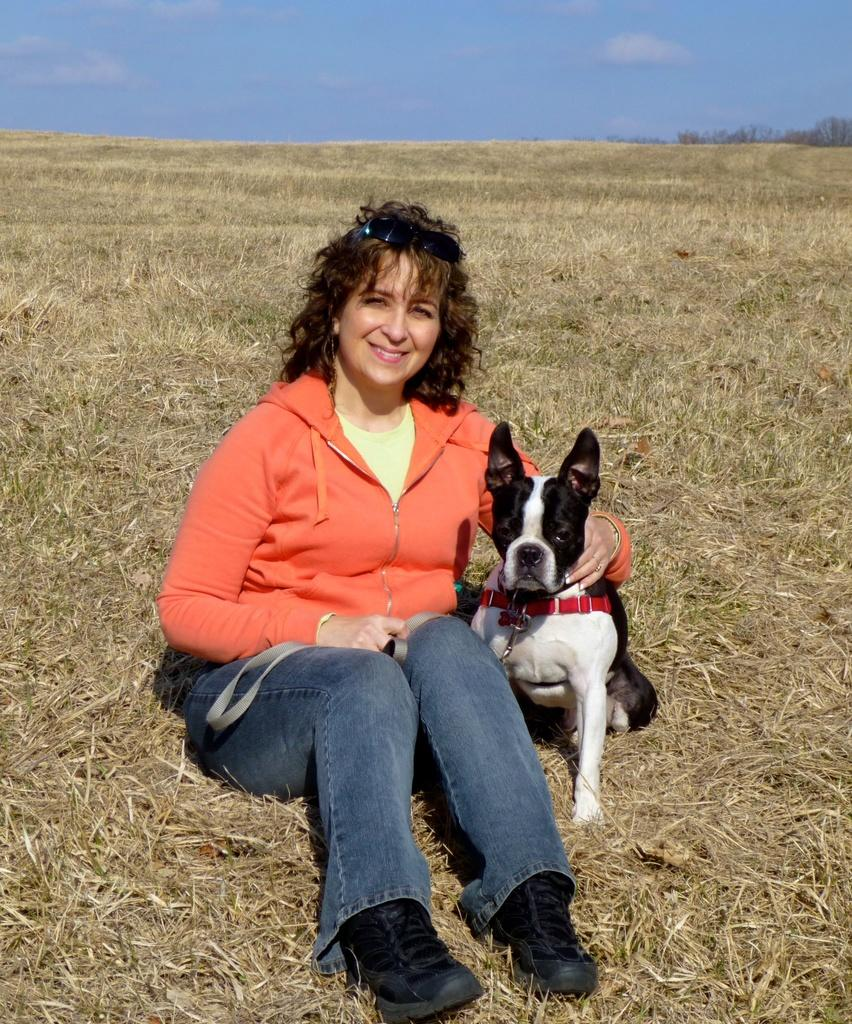What is the woman doing in the image? The woman is sitting in the grass in the image. Is there any other living creature present in the image? Yes, there is a dog beside the woman. Can you describe the appearance of the dog? The dog is black and white. What is the woman wearing in the image? The woman is wearing an orange sweater. What is the woman's facial expression in the image? The woman is smiling. What type of drain is visible in the image? There is no drain present in the image. How does the woman's wealth contribute to the scene in the image? The image does not provide any information about the woman's wealth, so it cannot be determined how it contributes to the scene. 